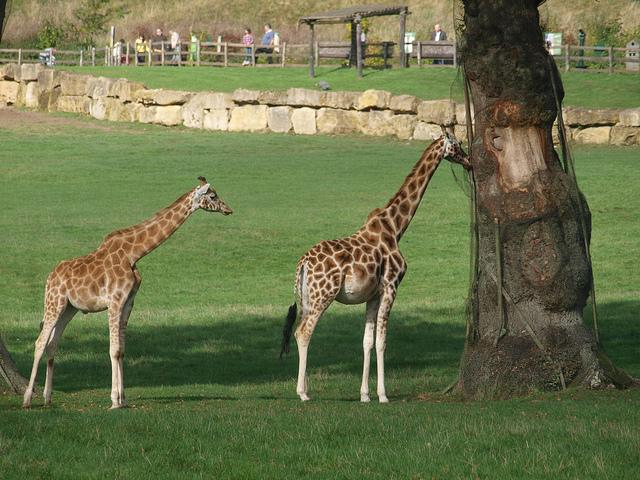What is there a giant hole taken out of the tree for?

Choices:
A) giraffes
B) moose
C) lumberjacks
D) skunks giraffes 